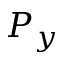Convert formula to latex. <formula><loc_0><loc_0><loc_500><loc_500>P _ { y }</formula> 